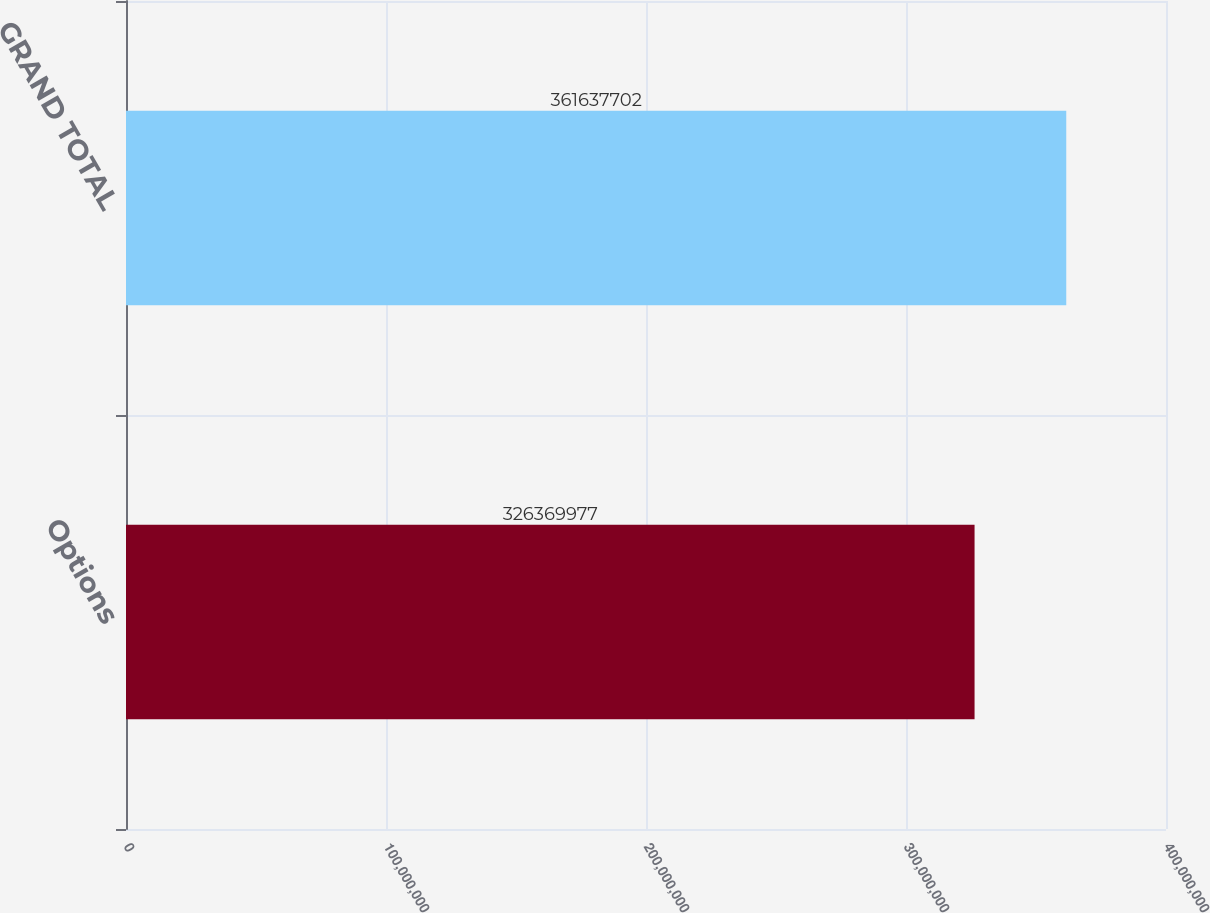Convert chart. <chart><loc_0><loc_0><loc_500><loc_500><bar_chart><fcel>Options<fcel>GRAND TOTAL<nl><fcel>3.2637e+08<fcel>3.61638e+08<nl></chart> 